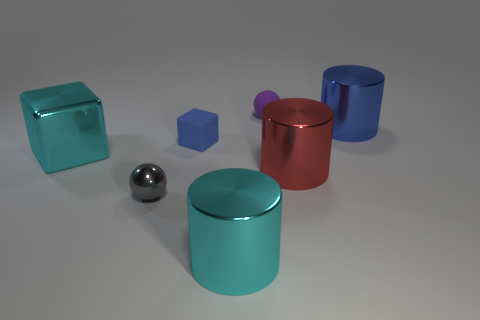How many large objects are either cyan rubber balls or red metallic objects?
Your answer should be compact. 1. Does the gray metal thing have the same shape as the purple thing?
Offer a very short reply. Yes. How many large metal cylinders are in front of the red object and to the right of the tiny rubber sphere?
Give a very brief answer. 0. Is there any other thing that is the same color as the big block?
Your answer should be compact. Yes. The blue thing that is made of the same material as the purple object is what shape?
Offer a terse response. Cube. Is the size of the shiny block the same as the gray sphere?
Your response must be concise. No. Are the thing that is right of the red thing and the small gray thing made of the same material?
Provide a short and direct response. Yes. There is a sphere that is in front of the large blue shiny object on the right side of the large cyan block; what number of large objects are behind it?
Provide a short and direct response. 3. Does the big metallic object on the left side of the blue matte block have the same shape as the tiny blue thing?
Your answer should be compact. Yes. What number of objects are either blue rubber blocks or balls behind the cyan cube?
Ensure brevity in your answer.  2. 